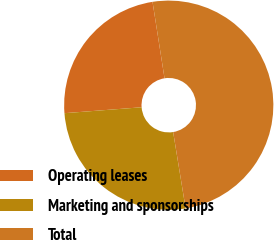Convert chart. <chart><loc_0><loc_0><loc_500><loc_500><pie_chart><fcel>Operating leases<fcel>Marketing and sponsorships<fcel>Total<nl><fcel>23.74%<fcel>26.36%<fcel>49.9%<nl></chart> 